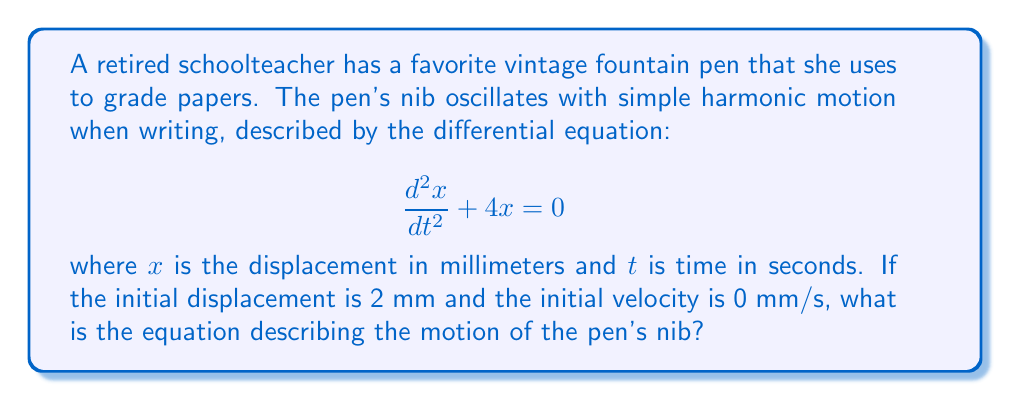Solve this math problem. 1) The general solution for a simple harmonic oscillator is:
   $$x(t) = A \cos(\omega t) + B \sin(\omega t)$$
   where $\omega$ is the angular frequency.

2) From the given differential equation, we can identify that $\omega^2 = 4$, so $\omega = 2$ rad/s.

3) Substituting this into our general solution:
   $$x(t) = A \cos(2t) + B \sin(2t)$$

4) We're given two initial conditions:
   - Initial displacement: $x(0) = 2$ mm
   - Initial velocity: $\frac{dx}{dt}(0) = 0$ mm/s

5) Using the first condition:
   $x(0) = A \cos(0) + B \sin(0) = A = 2$

6) For the second condition, we differentiate $x(t)$:
   $$\frac{dx}{dt} = -2A \sin(2t) + 2B \cos(2t)$$
   
   At $t=0$: $\frac{dx}{dt}(0) = 2B = 0$, so $B = 0$

7) Therefore, our solution is:
   $$x(t) = 2 \cos(2t)$$

This equation describes the motion of the pen's nib over time.
Answer: $x(t) = 2 \cos(2t)$ 